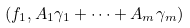Convert formula to latex. <formula><loc_0><loc_0><loc_500><loc_500>( f _ { 1 } , A _ { 1 } \gamma _ { 1 } + \cdots + A _ { m } \gamma _ { m } )</formula> 